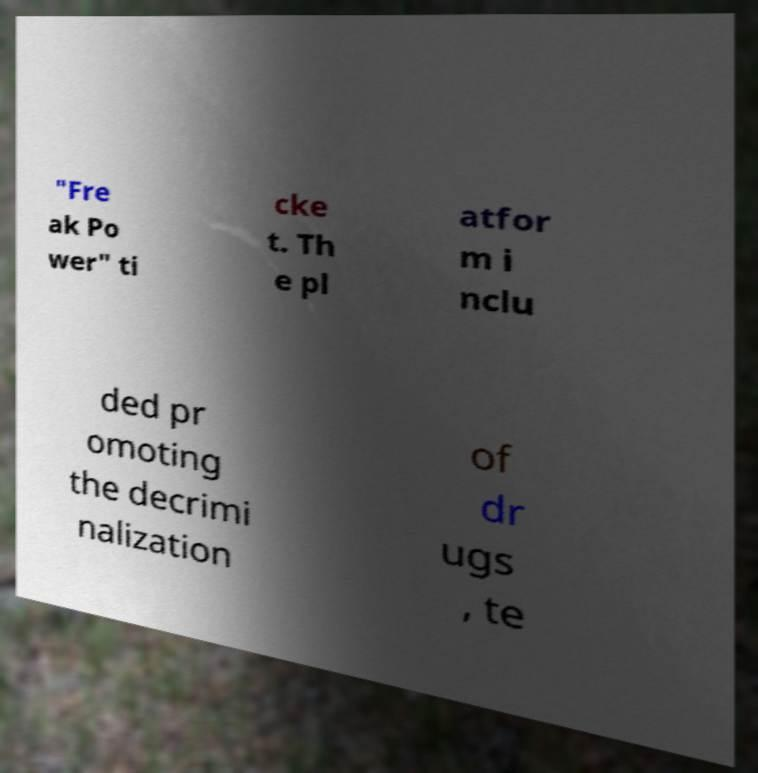Could you extract and type out the text from this image? "Fre ak Po wer" ti cke t. Th e pl atfor m i nclu ded pr omoting the decrimi nalization of dr ugs , te 